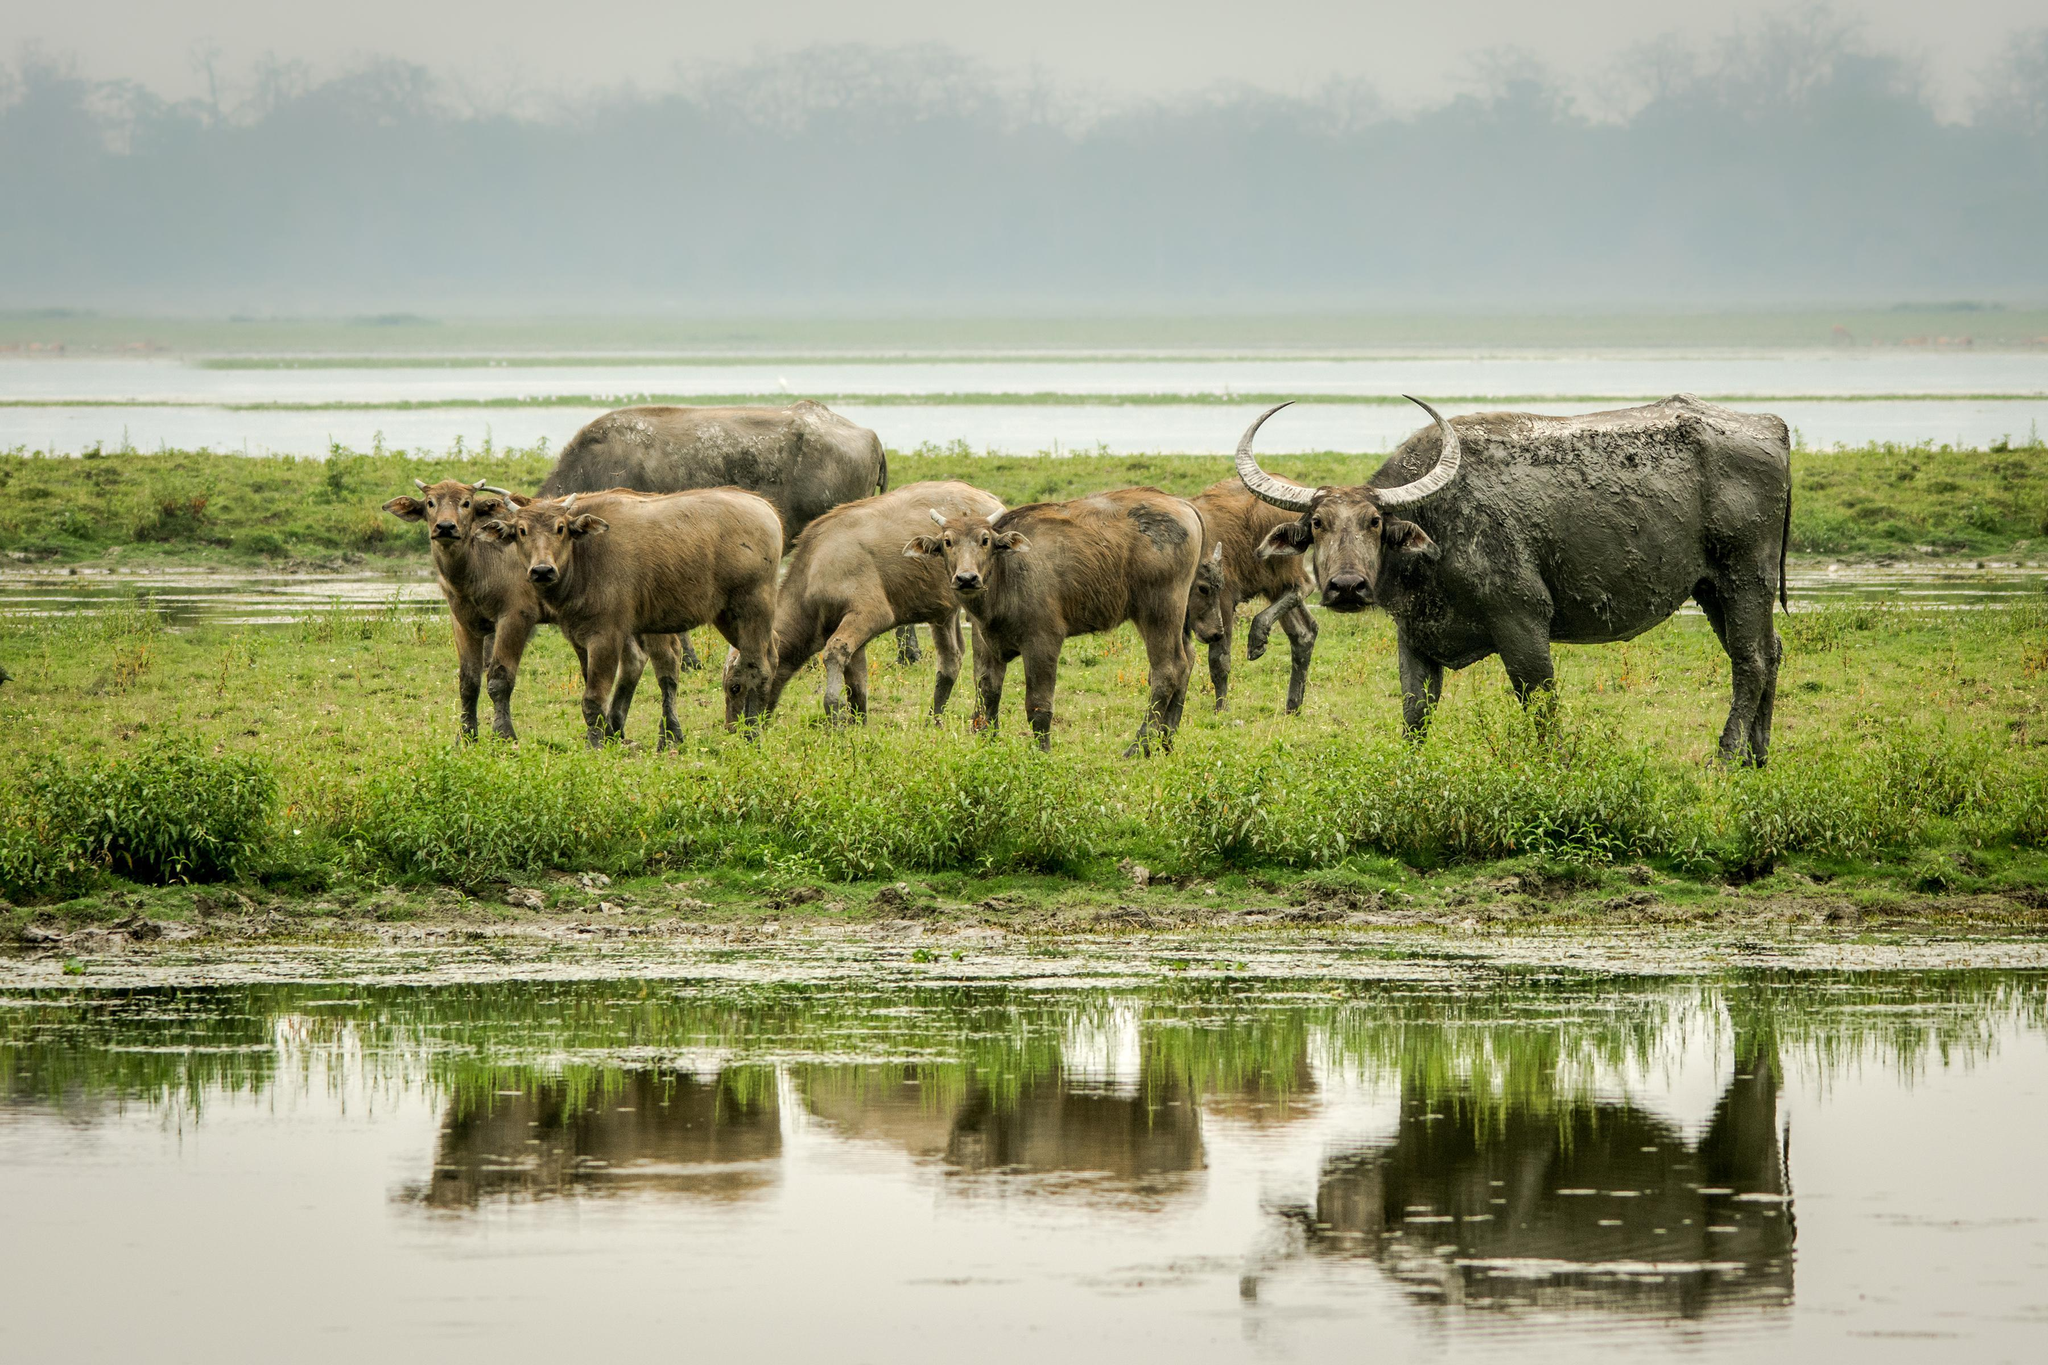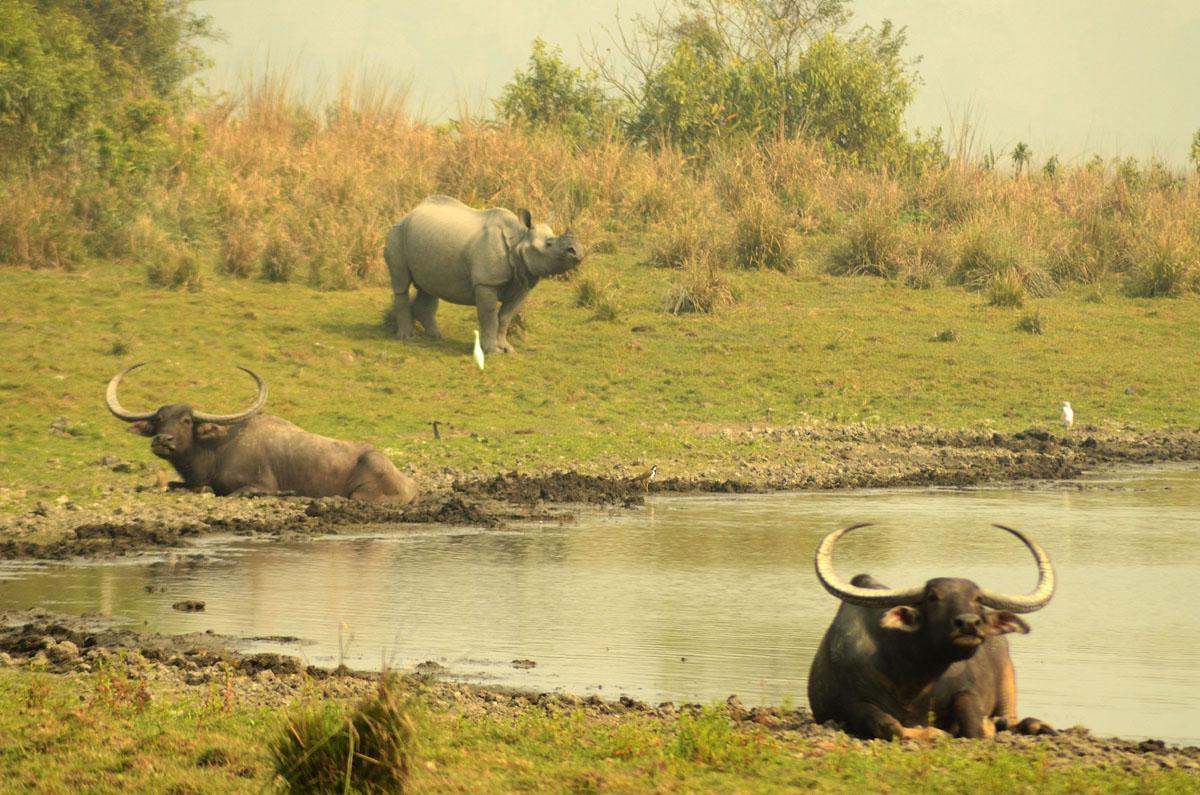The first image is the image on the left, the second image is the image on the right. Examine the images to the left and right. Is the description "Water bufallos are standing in water." accurate? Answer yes or no. No. The first image is the image on the left, the second image is the image on the right. Examine the images to the left and right. Is the description "All images show water buffalo in the water." accurate? Answer yes or no. No. 